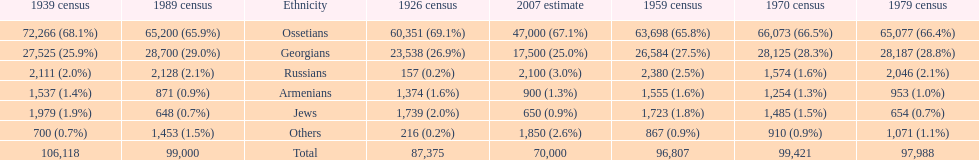How many ethnicities were below 1,000 people in 2007? 2. 